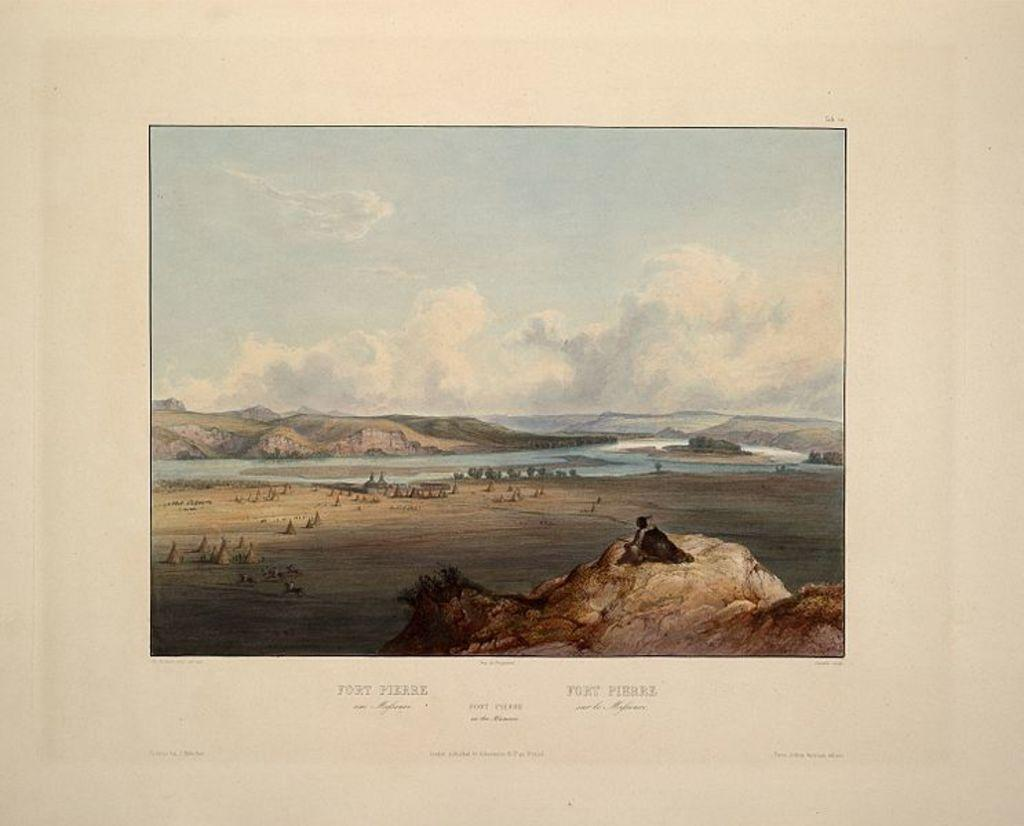What is the main object in the image? There is a paper in the image. What is depicted on the paper? The paper contains a painting. Is there any writing on the paper? Yes, there is text written on the paper. What color is the secretary's lipstick in the image? There is no secretary or lipstick present in the image; it features a paper with a painting and text. 